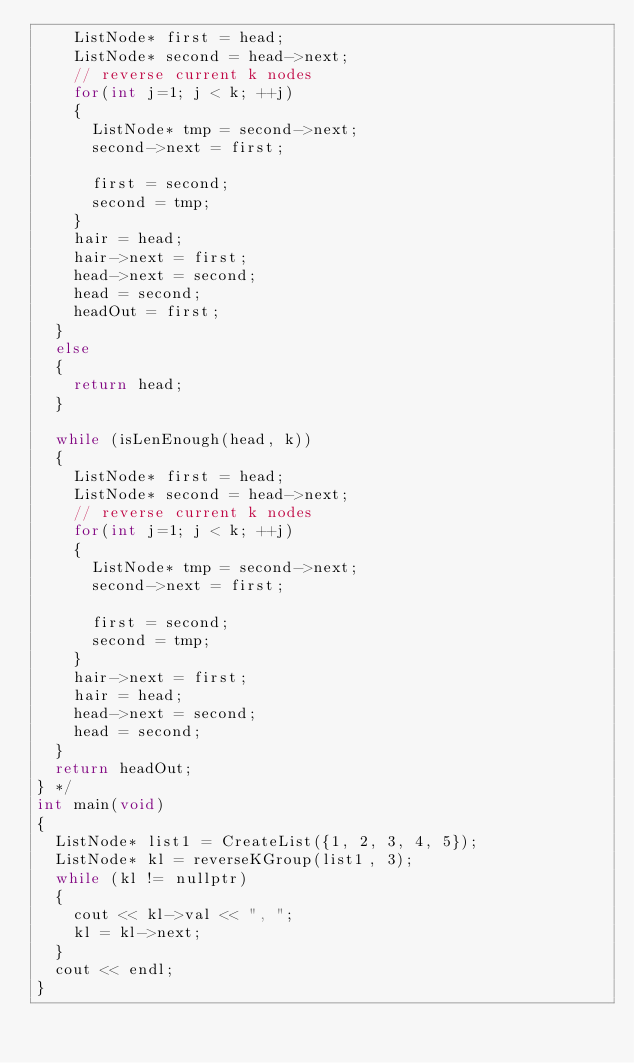Convert code to text. <code><loc_0><loc_0><loc_500><loc_500><_C++_>		ListNode* first = head;
		ListNode* second = head->next;
		// reverse current k nodes
		for(int j=1; j < k; ++j)
		{
			ListNode* tmp = second->next;
			second->next = first;

			first = second;
			second = tmp;
		}
		hair = head;
		hair->next = first;
		head->next = second;
		head = second;
		headOut = first;
	}
	else
	{
		return head;
	}

	while (isLenEnough(head, k))
	{
		ListNode* first = head;
		ListNode* second = head->next;
		// reverse current k nodes
		for(int j=1; j < k; ++j)
		{
			ListNode* tmp = second->next;
			second->next = first;

			first = second;
			second = tmp;
		}
		hair->next = first;
		hair = head;
		head->next = second;
		head = second;
	}
	return headOut;
} */
int main(void)
{
	ListNode* list1 = CreateList({1, 2, 3, 4, 5});
	ListNode* kl = reverseKGroup(list1, 3);
	while (kl != nullptr)
	{
		cout << kl->val << ", ";
		kl = kl->next;
	}
	cout << endl;
}
</code> 